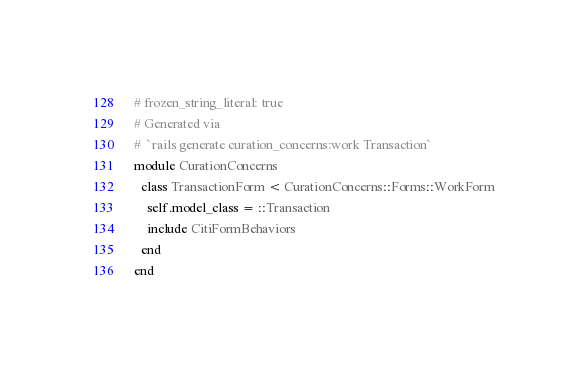<code> <loc_0><loc_0><loc_500><loc_500><_Ruby_># frozen_string_literal: true
# Generated via
#  `rails generate curation_concerns:work Transaction`
module CurationConcerns
  class TransactionForm < CurationConcerns::Forms::WorkForm
    self.model_class = ::Transaction
    include CitiFormBehaviors
  end
end
</code> 